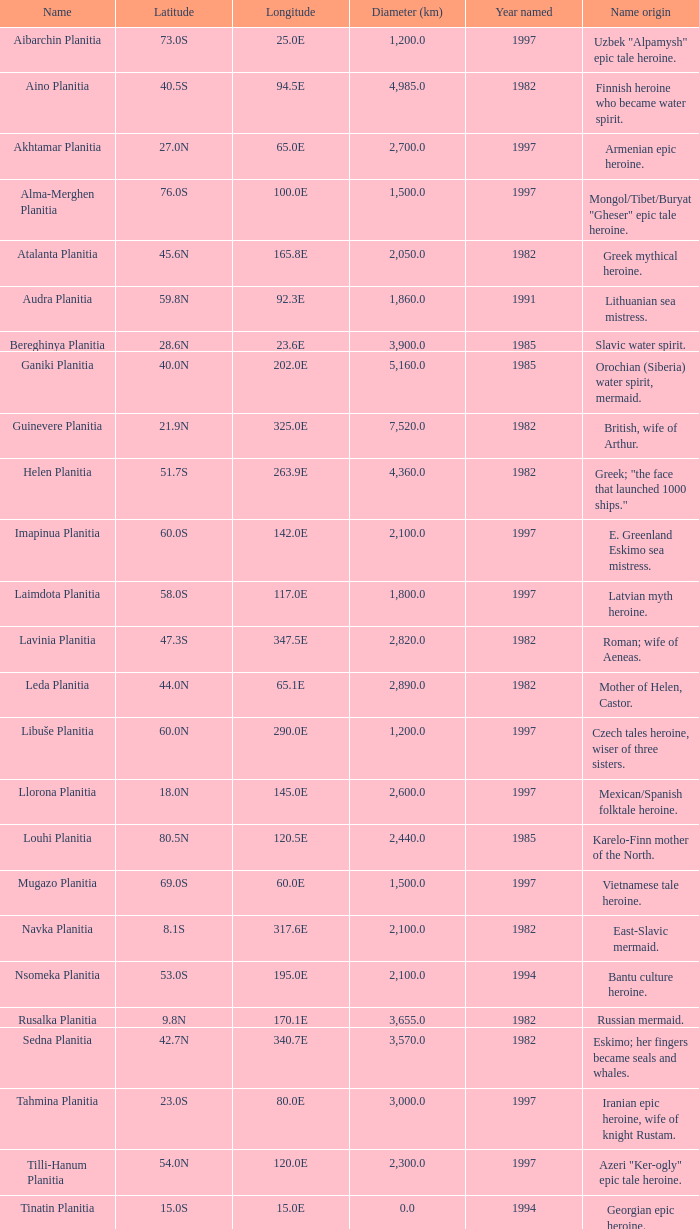0? Karelo-Finn mermaid. 